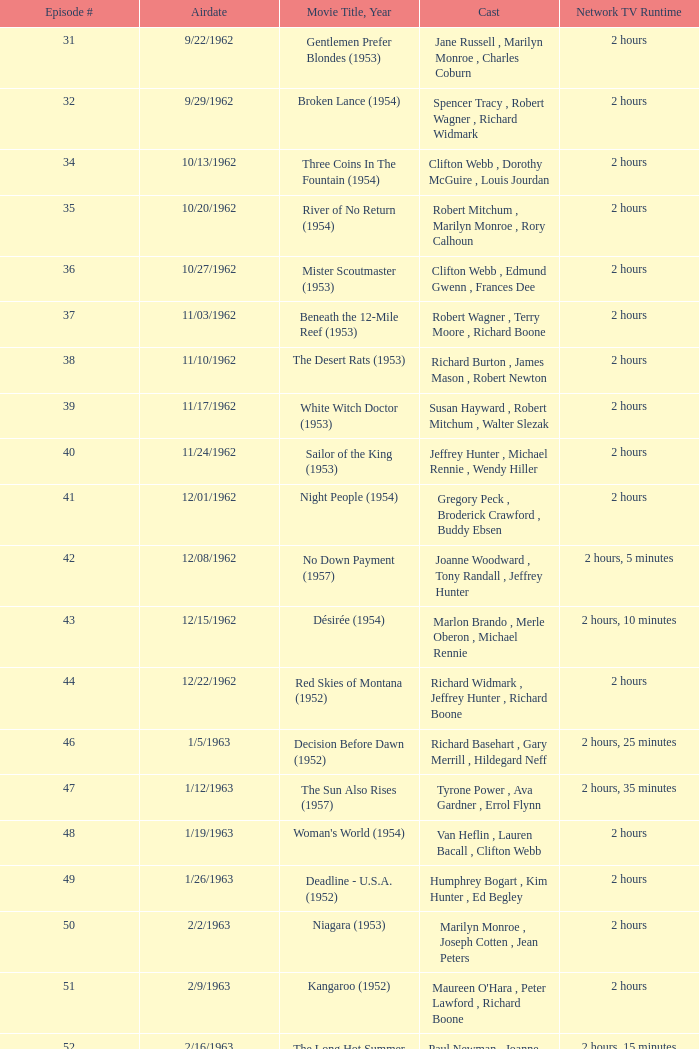Who was the cast on the 3/23/1963 episode? Dana Wynter , Mel Ferrer , Theodore Bikel. 